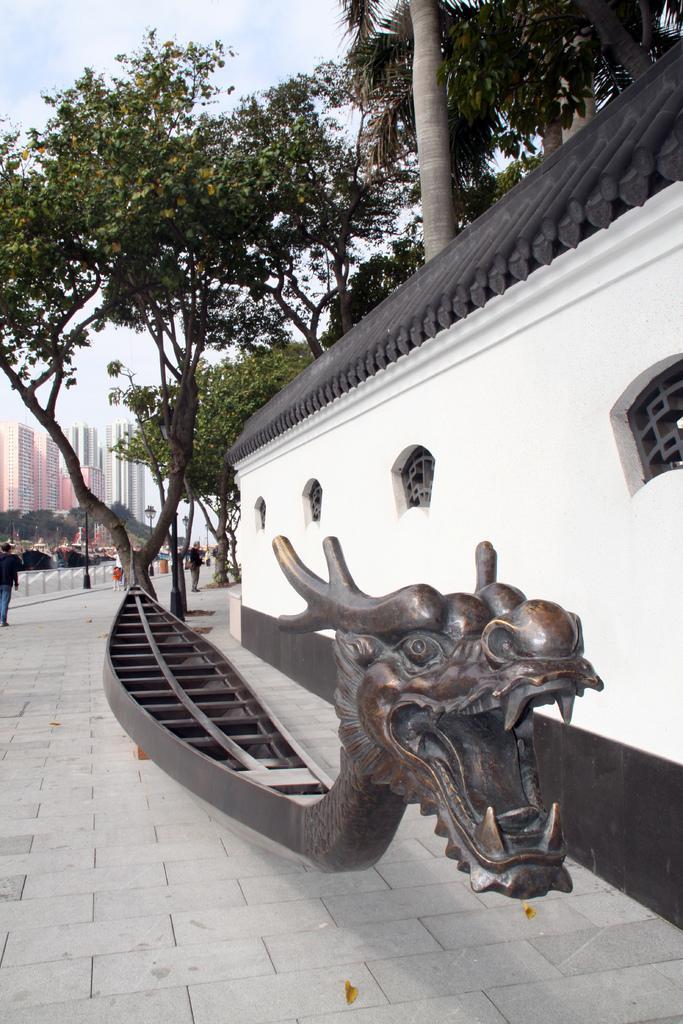Describe this image in one or two sentences. In this image in the front there is an object which is brown in colour. On the right side there is a wall. In the center there are trees and there are persons standing and walking. In the background there are buildings, trees and there is a black colour pole and there is a fence and the sky is cloudy. 